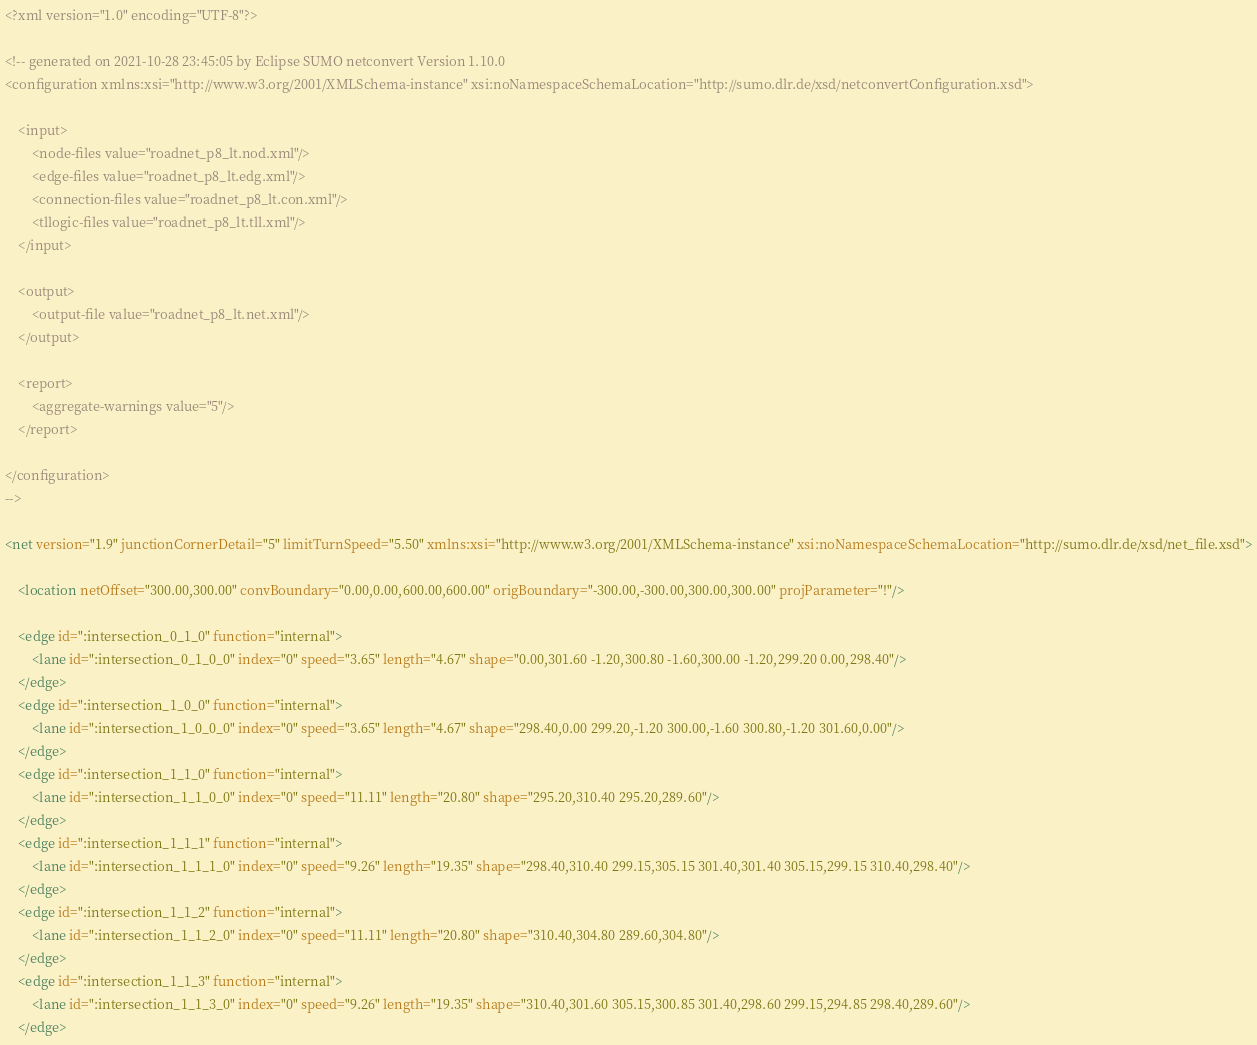Convert code to text. <code><loc_0><loc_0><loc_500><loc_500><_XML_><?xml version="1.0" encoding="UTF-8"?>

<!-- generated on 2021-10-28 23:45:05 by Eclipse SUMO netconvert Version 1.10.0
<configuration xmlns:xsi="http://www.w3.org/2001/XMLSchema-instance" xsi:noNamespaceSchemaLocation="http://sumo.dlr.de/xsd/netconvertConfiguration.xsd">

    <input>
        <node-files value="roadnet_p8_lt.nod.xml"/>
        <edge-files value="roadnet_p8_lt.edg.xml"/>
        <connection-files value="roadnet_p8_lt.con.xml"/>
        <tllogic-files value="roadnet_p8_lt.tll.xml"/>
    </input>

    <output>
        <output-file value="roadnet_p8_lt.net.xml"/>
    </output>

    <report>
        <aggregate-warnings value="5"/>
    </report>

</configuration>
-->

<net version="1.9" junctionCornerDetail="5" limitTurnSpeed="5.50" xmlns:xsi="http://www.w3.org/2001/XMLSchema-instance" xsi:noNamespaceSchemaLocation="http://sumo.dlr.de/xsd/net_file.xsd">

    <location netOffset="300.00,300.00" convBoundary="0.00,0.00,600.00,600.00" origBoundary="-300.00,-300.00,300.00,300.00" projParameter="!"/>

    <edge id=":intersection_0_1_0" function="internal">
        <lane id=":intersection_0_1_0_0" index="0" speed="3.65" length="4.67" shape="0.00,301.60 -1.20,300.80 -1.60,300.00 -1.20,299.20 0.00,298.40"/>
    </edge>
    <edge id=":intersection_1_0_0" function="internal">
        <lane id=":intersection_1_0_0_0" index="0" speed="3.65" length="4.67" shape="298.40,0.00 299.20,-1.20 300.00,-1.60 300.80,-1.20 301.60,0.00"/>
    </edge>
    <edge id=":intersection_1_1_0" function="internal">
        <lane id=":intersection_1_1_0_0" index="0" speed="11.11" length="20.80" shape="295.20,310.40 295.20,289.60"/>
    </edge>
    <edge id=":intersection_1_1_1" function="internal">
        <lane id=":intersection_1_1_1_0" index="0" speed="9.26" length="19.35" shape="298.40,310.40 299.15,305.15 301.40,301.40 305.15,299.15 310.40,298.40"/>
    </edge>
    <edge id=":intersection_1_1_2" function="internal">
        <lane id=":intersection_1_1_2_0" index="0" speed="11.11" length="20.80" shape="310.40,304.80 289.60,304.80"/>
    </edge>
    <edge id=":intersection_1_1_3" function="internal">
        <lane id=":intersection_1_1_3_0" index="0" speed="9.26" length="19.35" shape="310.40,301.60 305.15,300.85 301.40,298.60 299.15,294.85 298.40,289.60"/>
    </edge></code> 